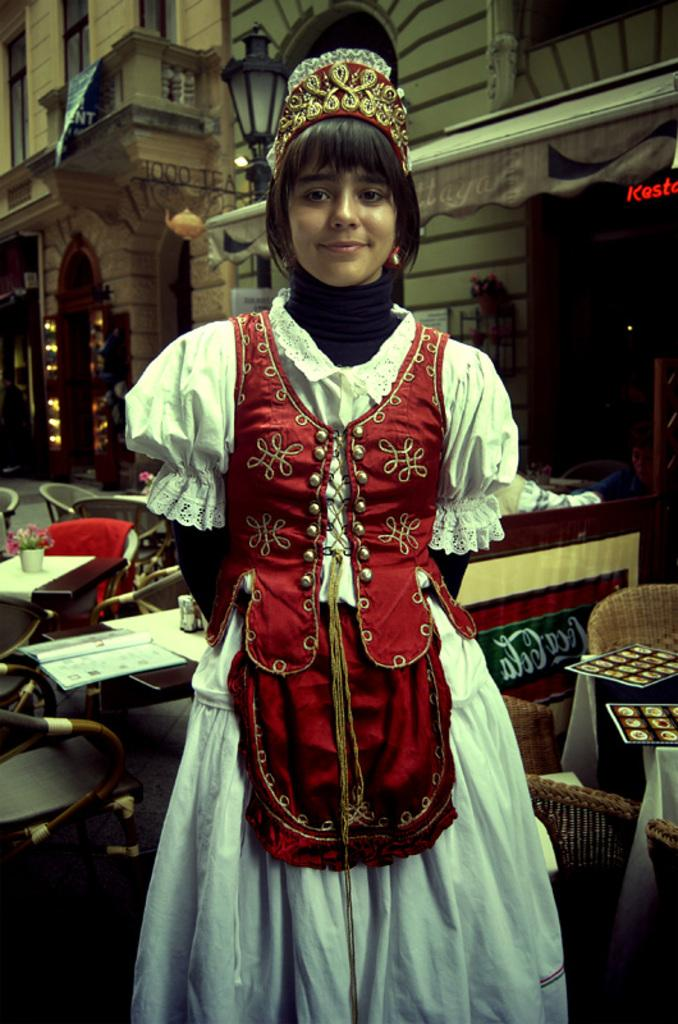Who is the main subject in the image? There is a woman standing in the center of the image. What is the woman doing in the image? The woman is posing for the picture. What can be seen in the background of the image? There is a building in the background of the image. What type of furniture is present in the image? Tables and chairs are present in the image. Are there any other objects visible in the image? Yes, there are other objects visible in the image. What type of linen is draped over the cave in the image? There is no cave or linen present in the image. How many oranges are visible on the table in the image? There are no oranges visible in the image. 